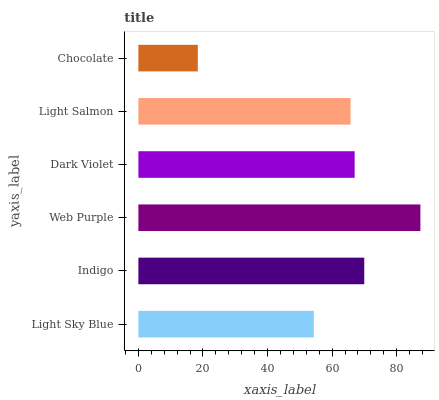Is Chocolate the minimum?
Answer yes or no. Yes. Is Web Purple the maximum?
Answer yes or no. Yes. Is Indigo the minimum?
Answer yes or no. No. Is Indigo the maximum?
Answer yes or no. No. Is Indigo greater than Light Sky Blue?
Answer yes or no. Yes. Is Light Sky Blue less than Indigo?
Answer yes or no. Yes. Is Light Sky Blue greater than Indigo?
Answer yes or no. No. Is Indigo less than Light Sky Blue?
Answer yes or no. No. Is Dark Violet the high median?
Answer yes or no. Yes. Is Light Salmon the low median?
Answer yes or no. Yes. Is Indigo the high median?
Answer yes or no. No. Is Indigo the low median?
Answer yes or no. No. 